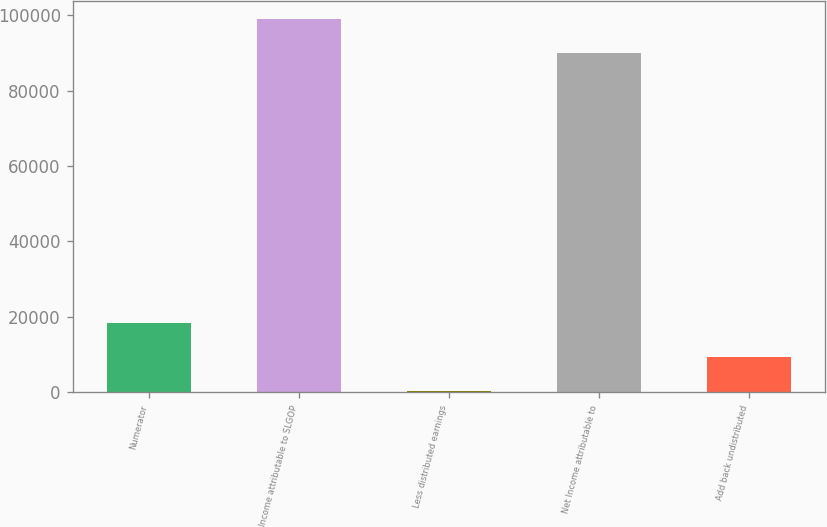Convert chart. <chart><loc_0><loc_0><loc_500><loc_500><bar_chart><fcel>Numerator<fcel>Income attributable to SLGOP<fcel>Less distributed earnings<fcel>Net Income attributable to<fcel>Add back undistributed<nl><fcel>18460.6<fcel>98942.8<fcel>471<fcel>89948<fcel>9465.8<nl></chart> 